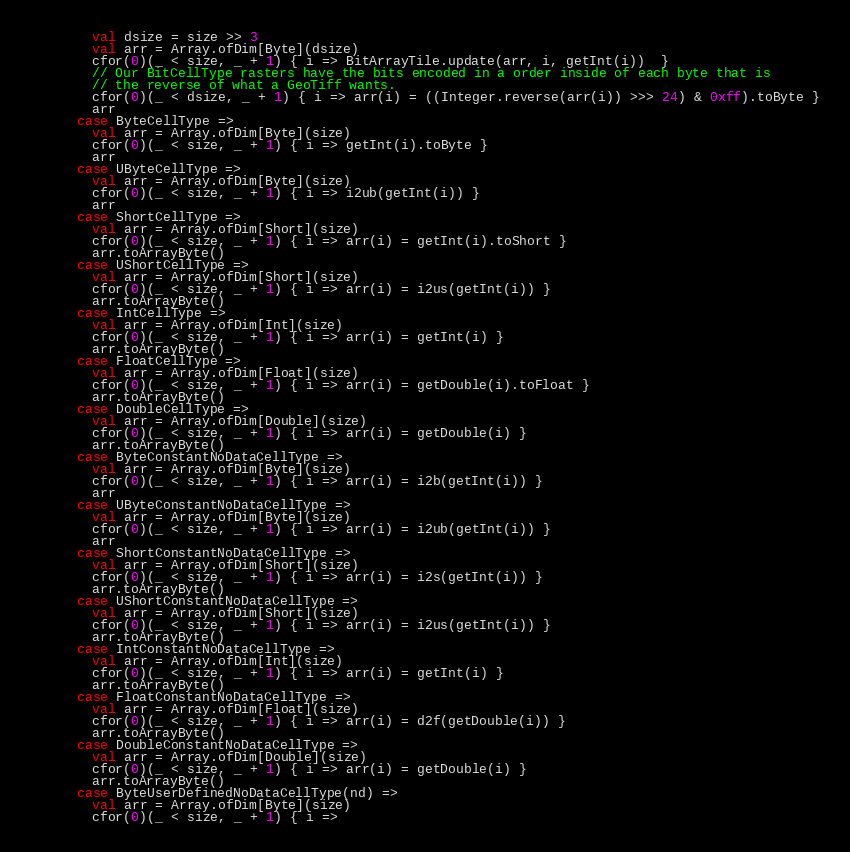<code> <loc_0><loc_0><loc_500><loc_500><_Scala_>        val dsize = size >> 3
        val arr = Array.ofDim[Byte](dsize)
        cfor(0)(_ < size, _ + 1) { i => BitArrayTile.update(arr, i, getInt(i))  }
        // Our BitCellType rasters have the bits encoded in a order inside of each byte that is
        // the reverse of what a GeoTiff wants.
        cfor(0)(_ < dsize, _ + 1) { i => arr(i) = ((Integer.reverse(arr(i)) >>> 24) & 0xff).toByte }
        arr
      case ByteCellType =>
        val arr = Array.ofDim[Byte](size)
        cfor(0)(_ < size, _ + 1) { i => getInt(i).toByte }
        arr
      case UByteCellType =>
        val arr = Array.ofDim[Byte](size)
        cfor(0)(_ < size, _ + 1) { i => i2ub(getInt(i)) }
        arr
      case ShortCellType =>
        val arr = Array.ofDim[Short](size)
        cfor(0)(_ < size, _ + 1) { i => arr(i) = getInt(i).toShort }
        arr.toArrayByte()
      case UShortCellType =>
        val arr = Array.ofDim[Short](size)
        cfor(0)(_ < size, _ + 1) { i => arr(i) = i2us(getInt(i)) }
        arr.toArrayByte()
      case IntCellType =>
        val arr = Array.ofDim[Int](size)
        cfor(0)(_ < size, _ + 1) { i => arr(i) = getInt(i) }
        arr.toArrayByte()
      case FloatCellType =>
        val arr = Array.ofDim[Float](size)
        cfor(0)(_ < size, _ + 1) { i => arr(i) = getDouble(i).toFloat }
        arr.toArrayByte()
      case DoubleCellType =>
        val arr = Array.ofDim[Double](size)
        cfor(0)(_ < size, _ + 1) { i => arr(i) = getDouble(i) }
        arr.toArrayByte()
      case ByteConstantNoDataCellType =>
        val arr = Array.ofDim[Byte](size)
        cfor(0)(_ < size, _ + 1) { i => arr(i) = i2b(getInt(i)) }
        arr
      case UByteConstantNoDataCellType =>
        val arr = Array.ofDim[Byte](size)
        cfor(0)(_ < size, _ + 1) { i => arr(i) = i2ub(getInt(i)) }
        arr
      case ShortConstantNoDataCellType =>
        val arr = Array.ofDim[Short](size)
        cfor(0)(_ < size, _ + 1) { i => arr(i) = i2s(getInt(i)) }
        arr.toArrayByte()
      case UShortConstantNoDataCellType =>
        val arr = Array.ofDim[Short](size)
        cfor(0)(_ < size, _ + 1) { i => arr(i) = i2us(getInt(i)) }
        arr.toArrayByte()
      case IntConstantNoDataCellType =>
        val arr = Array.ofDim[Int](size)
        cfor(0)(_ < size, _ + 1) { i => arr(i) = getInt(i) }
        arr.toArrayByte()
      case FloatConstantNoDataCellType =>
        val arr = Array.ofDim[Float](size)
        cfor(0)(_ < size, _ + 1) { i => arr(i) = d2f(getDouble(i)) }
        arr.toArrayByte()
      case DoubleConstantNoDataCellType =>
        val arr = Array.ofDim[Double](size)
        cfor(0)(_ < size, _ + 1) { i => arr(i) = getDouble(i) }
        arr.toArrayByte()
      case ByteUserDefinedNoDataCellType(nd) =>
        val arr = Array.ofDim[Byte](size)
        cfor(0)(_ < size, _ + 1) { i =></code> 